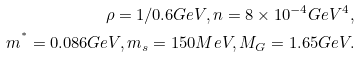<formula> <loc_0><loc_0><loc_500><loc_500>\rho = 1 / 0 . 6 G e V , n = 8 \times 1 0 ^ { - 4 } G e V ^ { 4 } , \\ m ^ { ^ { * } } = 0 . 0 8 6 G e V , m _ { s } = 1 5 0 M e V , M _ { G } = 1 . 6 5 G e V .</formula> 